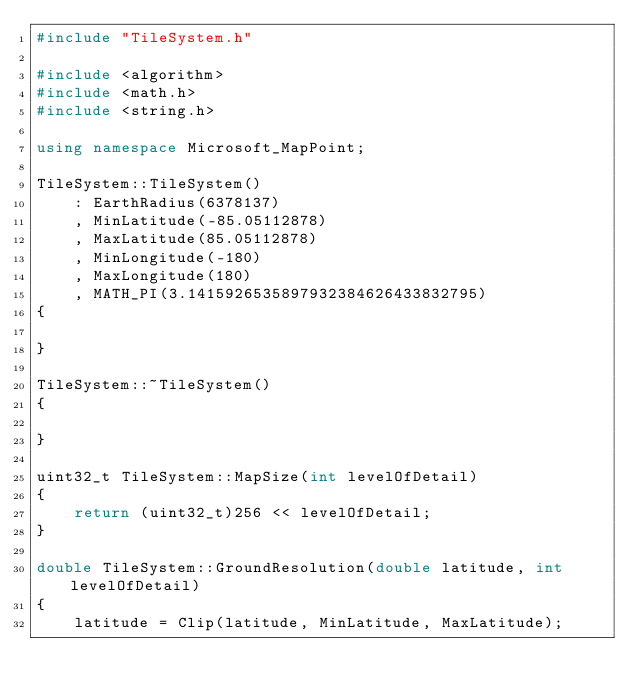<code> <loc_0><loc_0><loc_500><loc_500><_C++_>#include "TileSystem.h"

#include <algorithm>
#include <math.h>
#include <string.h>

using namespace Microsoft_MapPoint;

TileSystem::TileSystem()
    : EarthRadius(6378137)
    , MinLatitude(-85.05112878)
    , MaxLatitude(85.05112878)
    , MinLongitude(-180)
    , MaxLongitude(180)
    , MATH_PI(3.1415926535897932384626433832795)
{

}

TileSystem::~TileSystem()
{

}
 
uint32_t TileSystem::MapSize(int levelOfDetail)
{
    return (uint32_t)256 << levelOfDetail;
}

double TileSystem::GroundResolution(double latitude, int levelOfDetail)
{
    latitude = Clip(latitude, MinLatitude, MaxLatitude);</code> 